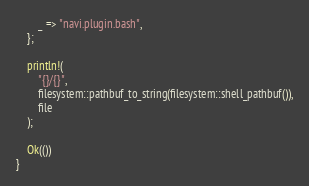Convert code to text. <code><loc_0><loc_0><loc_500><loc_500><_Rust_>        _ => "navi.plugin.bash",
    };

    println!(
        "{}/{}",
        filesystem::pathbuf_to_string(filesystem::shell_pathbuf()),
        file
    );

    Ok(())
}
</code> 